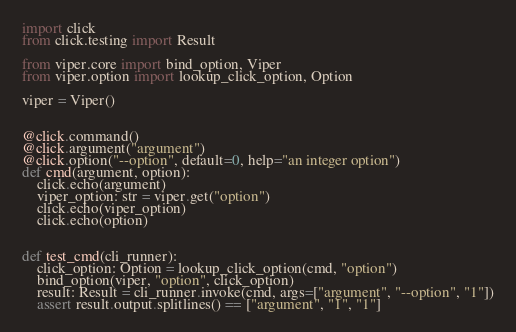Convert code to text. <code><loc_0><loc_0><loc_500><loc_500><_Python_>import click
from click.testing import Result

from viper.core import bind_option, Viper
from viper.option import lookup_click_option, Option

viper = Viper()


@click.command()
@click.argument("argument")
@click.option("--option", default=0, help="an integer option")
def cmd(argument, option):
    click.echo(argument)
    viper_option: str = viper.get("option")
    click.echo(viper_option)
    click.echo(option)


def test_cmd(cli_runner):
    click_option: Option = lookup_click_option(cmd, "option")
    bind_option(viper, "option", click_option)
    result: Result = cli_runner.invoke(cmd, args=["argument", "--option", "1"])
    assert result.output.splitlines() == ["argument", "1", "1"]
</code> 